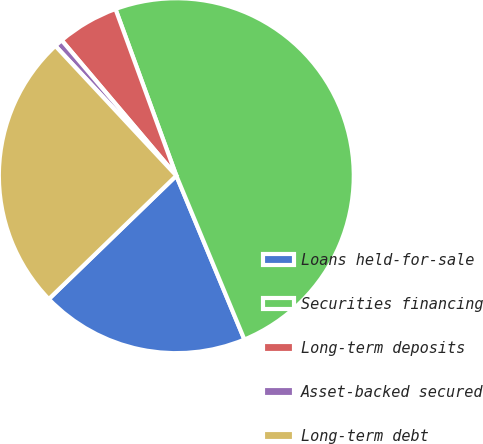Convert chart to OTSL. <chart><loc_0><loc_0><loc_500><loc_500><pie_chart><fcel>Loans held-for-sale<fcel>Securities financing<fcel>Long-term deposits<fcel>Asset-backed secured<fcel>Long-term debt<nl><fcel>19.03%<fcel>49.31%<fcel>5.61%<fcel>0.76%<fcel>25.3%<nl></chart> 